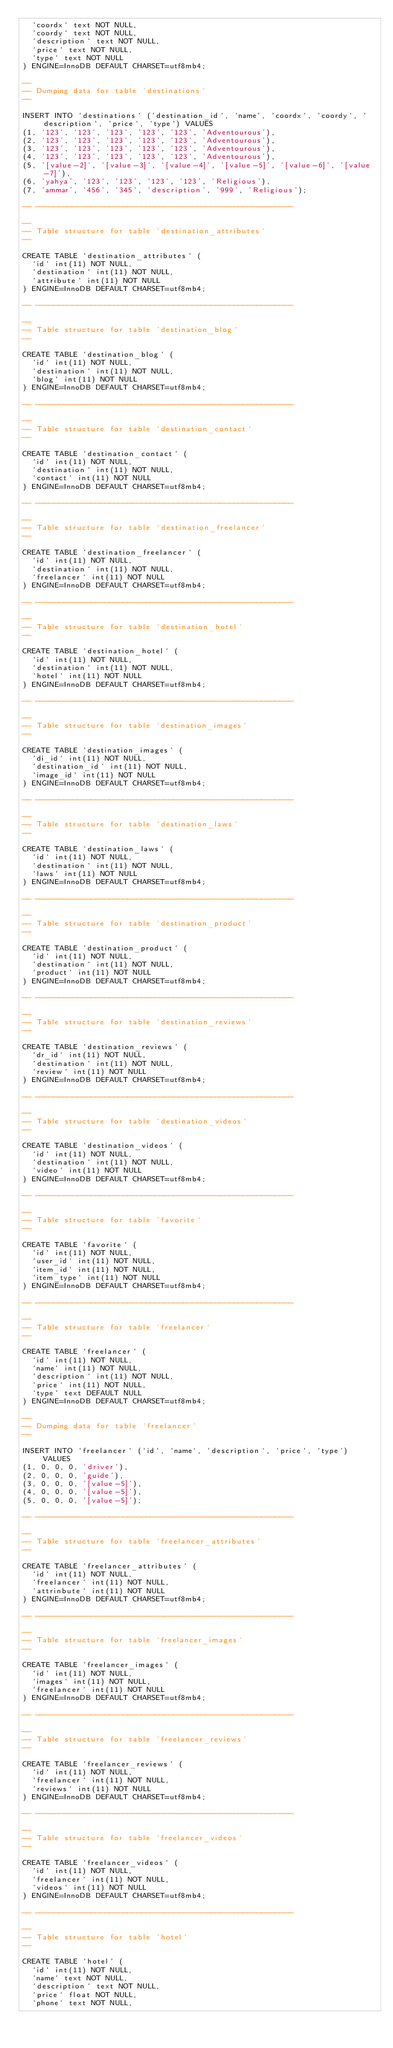Convert code to text. <code><loc_0><loc_0><loc_500><loc_500><_SQL_>  `coordx` text NOT NULL,
  `coordy` text NOT NULL,
  `description` text NOT NULL,
  `price` text NOT NULL,
  `type` text NOT NULL
) ENGINE=InnoDB DEFAULT CHARSET=utf8mb4;

--
-- Dumping data for table `destinations`
--

INSERT INTO `destinations` (`destination_id`, `name`, `coordx`, `coordy`, `description`, `price`, `type`) VALUES
(1, '123', '123', '123', '123', '123', 'Adventourous'),
(2, '123', '123', '123', '123', '123', 'Adventourous'),
(3, '123', '123', '123', '123', '123', 'Adventourous'),
(4, '123', '123', '123', '123', '123', 'Adventourous'),
(5, '[value-2]', '[value-3]', '[value-4]', '[value-5]', '[value-6]', '[value-7]'),
(6, 'yahya', '123', '123', '123', '123', 'Religious'),
(7, 'ammar', '456', '345', 'description', '999', 'Religious');

-- --------------------------------------------------------

--
-- Table structure for table `destination_attributes`
--

CREATE TABLE `destination_attributes` (
  `id` int(11) NOT NULL,
  `destination` int(11) NOT NULL,
  `attribute` int(11) NOT NULL
) ENGINE=InnoDB DEFAULT CHARSET=utf8mb4;

-- --------------------------------------------------------

--
-- Table structure for table `destination_blog`
--

CREATE TABLE `destination_blog` (
  `id` int(11) NOT NULL,
  `destination` int(11) NOT NULL,
  `blog` int(11) NOT NULL
) ENGINE=InnoDB DEFAULT CHARSET=utf8mb4;

-- --------------------------------------------------------

--
-- Table structure for table `destination_contact`
--

CREATE TABLE `destination_contact` (
  `id` int(11) NOT NULL,
  `destination` int(11) NOT NULL,
  `contact` int(11) NOT NULL
) ENGINE=InnoDB DEFAULT CHARSET=utf8mb4;

-- --------------------------------------------------------

--
-- Table structure for table `destination_freelancer`
--

CREATE TABLE `destination_freelancer` (
  `id` int(11) NOT NULL,
  `destination` int(11) NOT NULL,
  `freelancer` int(11) NOT NULL
) ENGINE=InnoDB DEFAULT CHARSET=utf8mb4;

-- --------------------------------------------------------

--
-- Table structure for table `destination_hotel`
--

CREATE TABLE `destination_hotel` (
  `id` int(11) NOT NULL,
  `destination` int(11) NOT NULL,
  `hotel` int(11) NOT NULL
) ENGINE=InnoDB DEFAULT CHARSET=utf8mb4;

-- --------------------------------------------------------

--
-- Table structure for table `destination_images`
--

CREATE TABLE `destination_images` (
  `di_id` int(11) NOT NULL,
  `destination_id` int(11) NOT NULL,
  `image_id` int(11) NOT NULL
) ENGINE=InnoDB DEFAULT CHARSET=utf8mb4;

-- --------------------------------------------------------

--
-- Table structure for table `destination_laws`
--

CREATE TABLE `destination_laws` (
  `id` int(11) NOT NULL,
  `destination` int(11) NOT NULL,
  `laws` int(11) NOT NULL
) ENGINE=InnoDB DEFAULT CHARSET=utf8mb4;

-- --------------------------------------------------------

--
-- Table structure for table `destination_product`
--

CREATE TABLE `destination_product` (
  `id` int(11) NOT NULL,
  `destination` int(11) NOT NULL,
  `product` int(11) NOT NULL
) ENGINE=InnoDB DEFAULT CHARSET=utf8mb4;

-- --------------------------------------------------------

--
-- Table structure for table `destination_reviews`
--

CREATE TABLE `destination_reviews` (
  `dr_id` int(11) NOT NULL,
  `destination` int(11) NOT NULL,
  `review` int(11) NOT NULL
) ENGINE=InnoDB DEFAULT CHARSET=utf8mb4;

-- --------------------------------------------------------

--
-- Table structure for table `destination_videos`
--

CREATE TABLE `destination_videos` (
  `id` int(11) NOT NULL,
  `destination` int(11) NOT NULL,
  `video` int(11) NOT NULL
) ENGINE=InnoDB DEFAULT CHARSET=utf8mb4;

-- --------------------------------------------------------

--
-- Table structure for table `favorite`
--

CREATE TABLE `favorite` (
  `id` int(11) NOT NULL,
  `user_id` int(11) NOT NULL,
  `item_id` int(11) NOT NULL,
  `item_type` int(11) NOT NULL
) ENGINE=InnoDB DEFAULT CHARSET=utf8mb4;

-- --------------------------------------------------------

--
-- Table structure for table `freelancer`
--

CREATE TABLE `freelancer` (
  `id` int(11) NOT NULL,
  `name` int(11) NOT NULL,
  `description` int(11) NOT NULL,
  `price` int(11) NOT NULL,
  `type` text DEFAULT NULL
) ENGINE=InnoDB DEFAULT CHARSET=utf8mb4;

--
-- Dumping data for table `freelancer`
--

INSERT INTO `freelancer` (`id`, `name`, `description`, `price`, `type`) VALUES
(1, 0, 0, 0, 'driver'),
(2, 0, 0, 0, 'guide'),
(3, 0, 0, 0, '[value-5]'),
(4, 0, 0, 0, '[value-5]'),
(5, 0, 0, 0, '[value-5]');

-- --------------------------------------------------------

--
-- Table structure for table `freelancer_attributes`
--

CREATE TABLE `freelancer_attributes` (
  `id` int(11) NOT NULL,
  `freelancer` int(11) NOT NULL,
  `attrinbute` int(11) NOT NULL
) ENGINE=InnoDB DEFAULT CHARSET=utf8mb4;

-- --------------------------------------------------------

--
-- Table structure for table `freelancer_images`
--

CREATE TABLE `freelancer_images` (
  `id` int(11) NOT NULL,
  `images` int(11) NOT NULL,
  `freelancer` int(11) NOT NULL
) ENGINE=InnoDB DEFAULT CHARSET=utf8mb4;

-- --------------------------------------------------------

--
-- Table structure for table `freelancer_reviews`
--

CREATE TABLE `freelancer_reviews` (
  `id` int(11) NOT NULL,
  `freelancer` int(11) NOT NULL,
  `reviews` int(11) NOT NULL
) ENGINE=InnoDB DEFAULT CHARSET=utf8mb4;

-- --------------------------------------------------------

--
-- Table structure for table `freelancer_videos`
--

CREATE TABLE `freelancer_videos` (
  `id` int(11) NOT NULL,
  `freelancer` int(11) NOT NULL,
  `videos` int(11) NOT NULL
) ENGINE=InnoDB DEFAULT CHARSET=utf8mb4;

-- --------------------------------------------------------

--
-- Table structure for table `hotel`
--

CREATE TABLE `hotel` (
  `id` int(11) NOT NULL,
  `name` text NOT NULL,
  `description` text NOT NULL,
  `price` float NOT NULL,
  `phone` text NOT NULL,</code> 